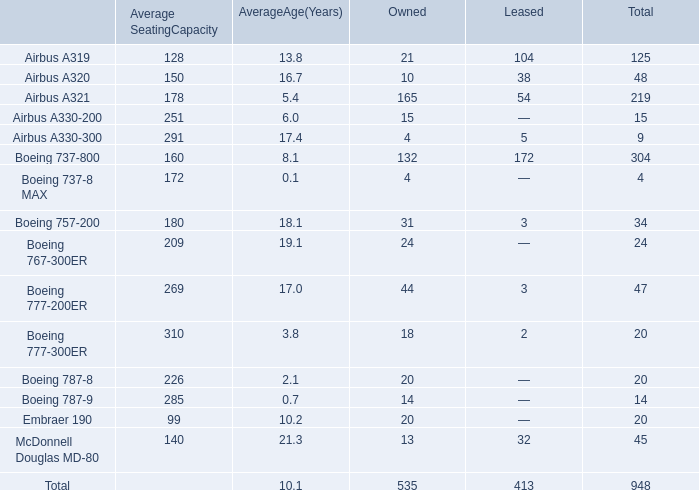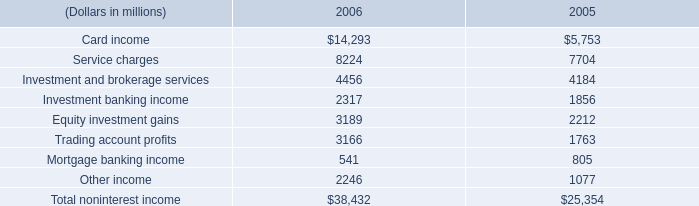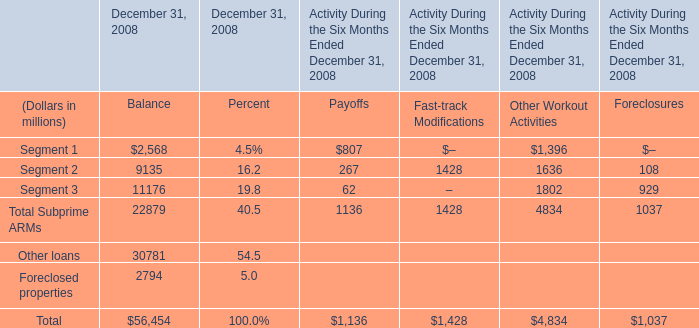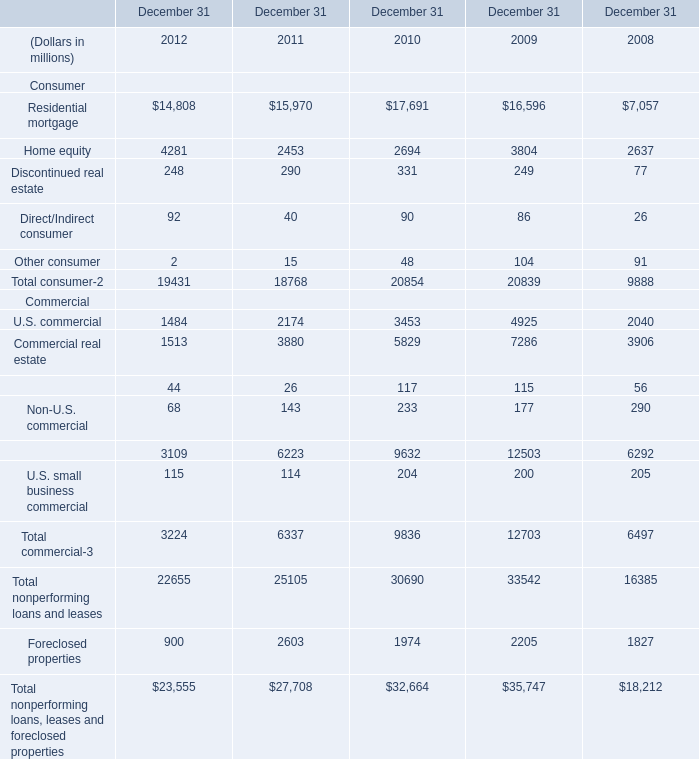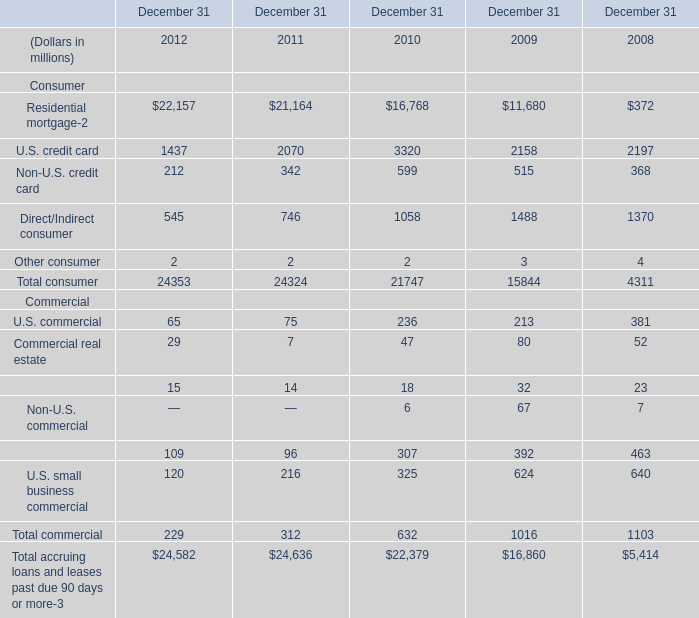What's the average of Service charges of 2005, and Commercial real estate Commercial of December 31 2008 ? 
Computations: ((7704.0 + 3906.0) / 2)
Answer: 5805.0. 